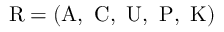Convert formula to latex. <formula><loc_0><loc_0><loc_500><loc_500>{ R } = ( { A , C , U , P , K } )</formula> 